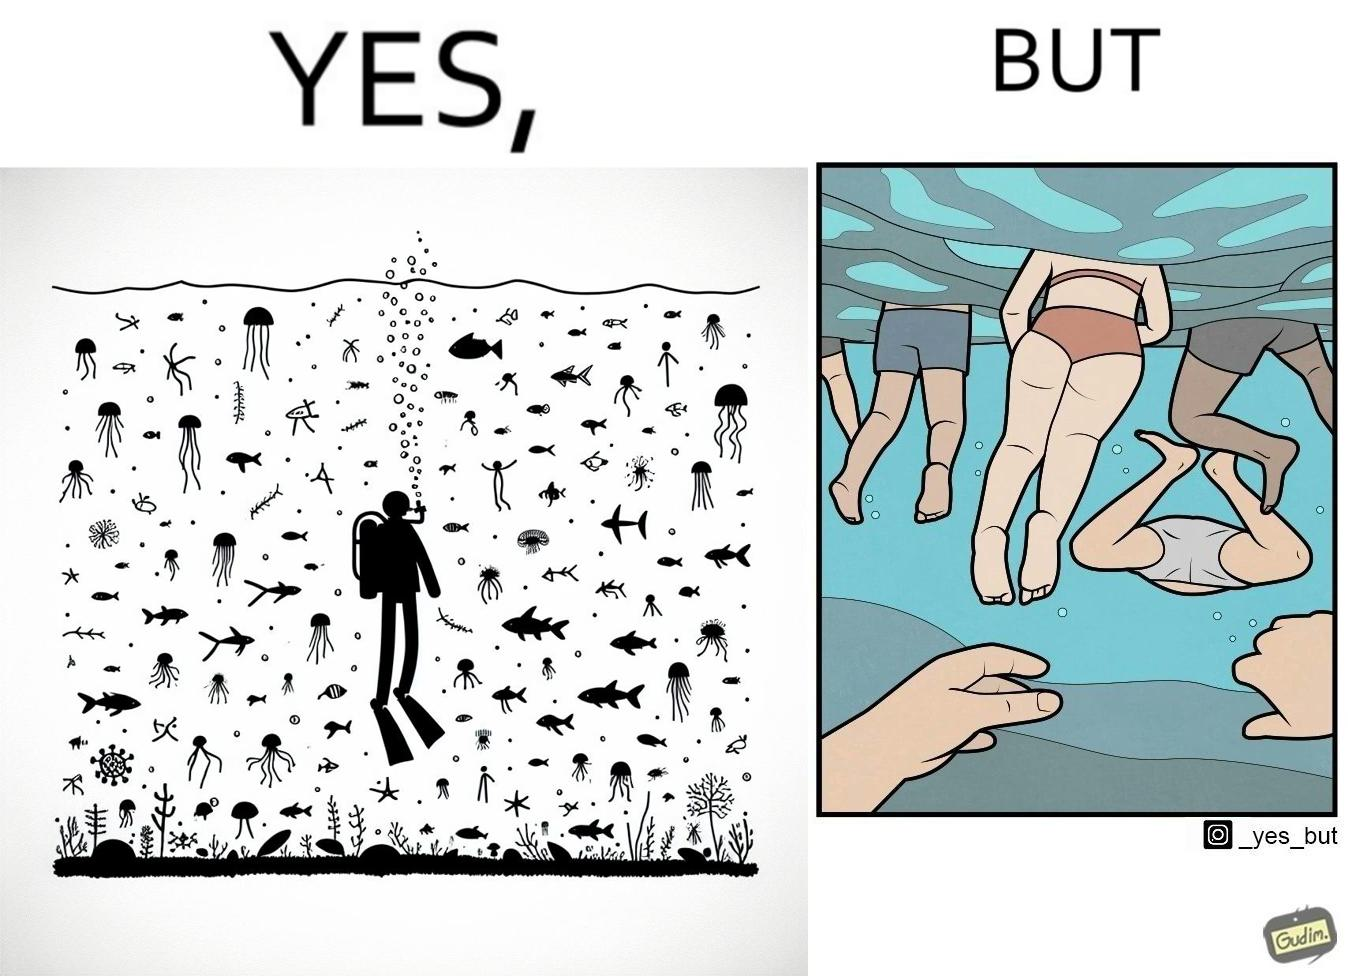Describe what you see in the left and right parts of this image. In the left part of the image: a person underwater exploring the biodiversity under water In the right part of the image: a person underwater watching people swimming in the water 